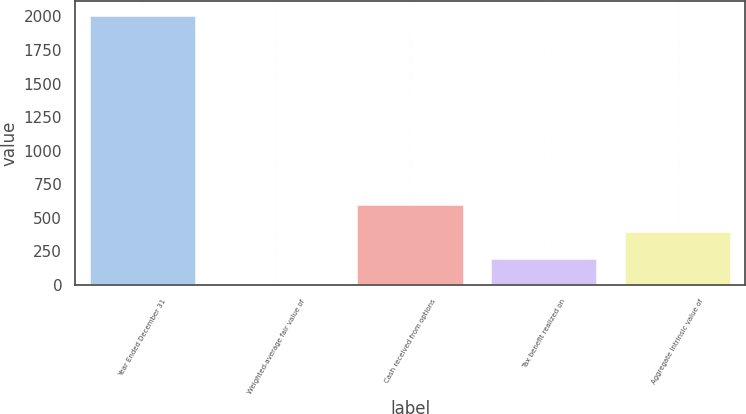Convert chart. <chart><loc_0><loc_0><loc_500><loc_500><bar_chart><fcel>Year Ended December 31<fcel>Weighted-average fair value of<fcel>Cash received from options<fcel>Tax benefit realized on<fcel>Aggregate intrinsic value of<nl><fcel>2011<fcel>4.16<fcel>606.2<fcel>204.84<fcel>405.52<nl></chart> 